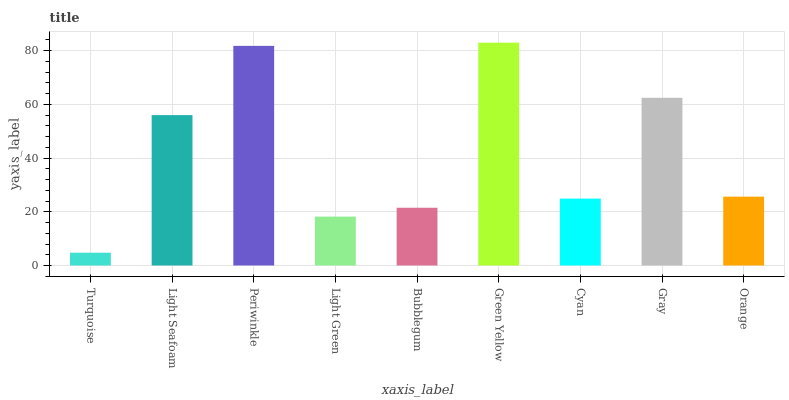Is Turquoise the minimum?
Answer yes or no. Yes. Is Green Yellow the maximum?
Answer yes or no. Yes. Is Light Seafoam the minimum?
Answer yes or no. No. Is Light Seafoam the maximum?
Answer yes or no. No. Is Light Seafoam greater than Turquoise?
Answer yes or no. Yes. Is Turquoise less than Light Seafoam?
Answer yes or no. Yes. Is Turquoise greater than Light Seafoam?
Answer yes or no. No. Is Light Seafoam less than Turquoise?
Answer yes or no. No. Is Orange the high median?
Answer yes or no. Yes. Is Orange the low median?
Answer yes or no. Yes. Is Green Yellow the high median?
Answer yes or no. No. Is Gray the low median?
Answer yes or no. No. 